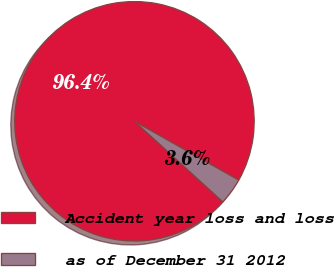<chart> <loc_0><loc_0><loc_500><loc_500><pie_chart><fcel>Accident year loss and loss<fcel>as of December 31 2012<nl><fcel>96.4%<fcel>3.6%<nl></chart> 